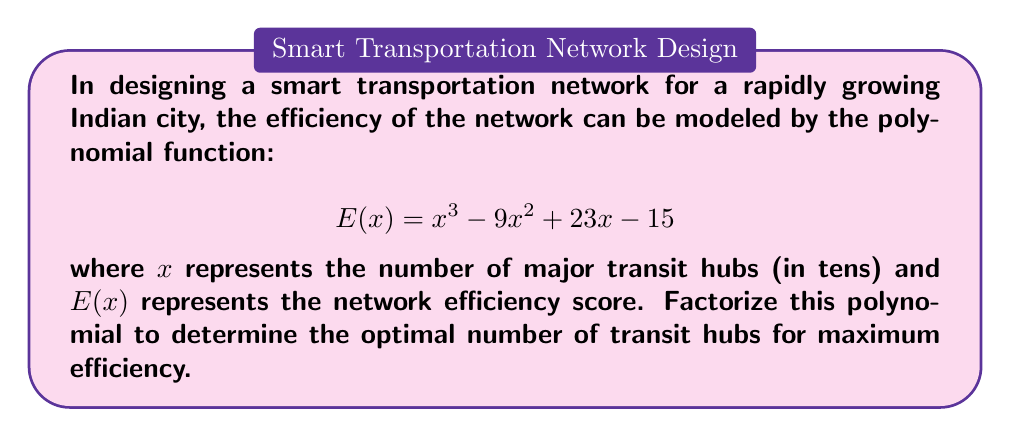Provide a solution to this math problem. To factorize the polynomial $E(x) = x^3 - 9x^2 + 23x - 15$, we'll follow these steps:

1) First, let's check if there's a common factor. There isn't, so we proceed.

2) Next, we'll use the rational root theorem to find potential roots. The factors of the constant term (15) are: ±1, ±3, ±5, ±15.

3) Testing these values, we find that $x = 1$ is a root. So $(x - 1)$ is a factor.

4) Divide the polynomial by $(x - 1)$ using polynomial long division:

   $$x^3 - 9x^2 + 23x - 15 = (x - 1)(x^2 - 8x + 15)$$

5) Now we need to factor the quadratic $x^2 - 8x + 15$. We can do this by finding two numbers that multiply to give 15 and add to give -8. These numbers are -3 and -5.

6) Therefore, $x^2 - 8x + 15 = (x - 3)(x - 5)$

7) Combining all factors, we get:

   $$E(x) = (x - 1)(x - 3)(x - 5)$$

8) The roots of this polynomial are $x = 1$, $x = 3$, and $x = 5$.

9) Since $x$ represents the number of major transit hubs in tens, these roots correspond to 10, 30, and 50 hubs.

10) The maximum efficiency will occur at the highest point of the cubic function, which is at the middle root, $x = 3$.

Therefore, the optimal number of transit hubs for maximum efficiency is 30.
Answer: $(x - 1)(x - 3)(x - 5)$; 30 hubs 